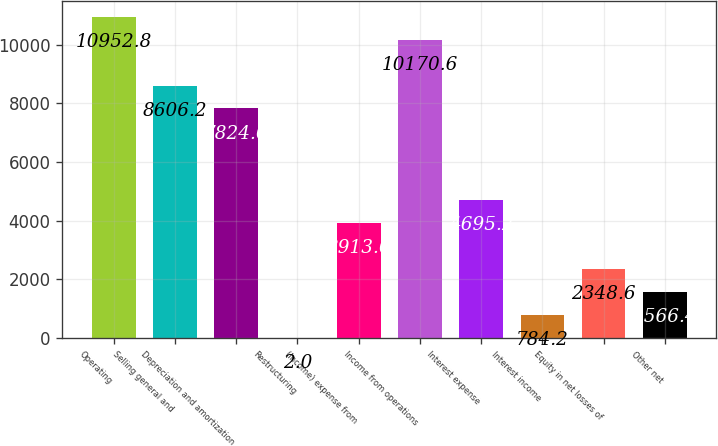Convert chart. <chart><loc_0><loc_0><loc_500><loc_500><bar_chart><fcel>Operating<fcel>Selling general and<fcel>Depreciation and amortization<fcel>Restructuring<fcel>(Income) expense from<fcel>Income from operations<fcel>Interest expense<fcel>Interest income<fcel>Equity in net losses of<fcel>Other net<nl><fcel>10952.8<fcel>8606.2<fcel>7824<fcel>2<fcel>3913<fcel>10170.6<fcel>4695.2<fcel>784.2<fcel>2348.6<fcel>1566.4<nl></chart> 